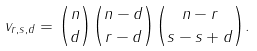Convert formula to latex. <formula><loc_0><loc_0><loc_500><loc_500>v _ { r , s , d } = \binom { n } { d } \binom { n - d } { r - d } \binom { n - r } { s - s + d } .</formula> 